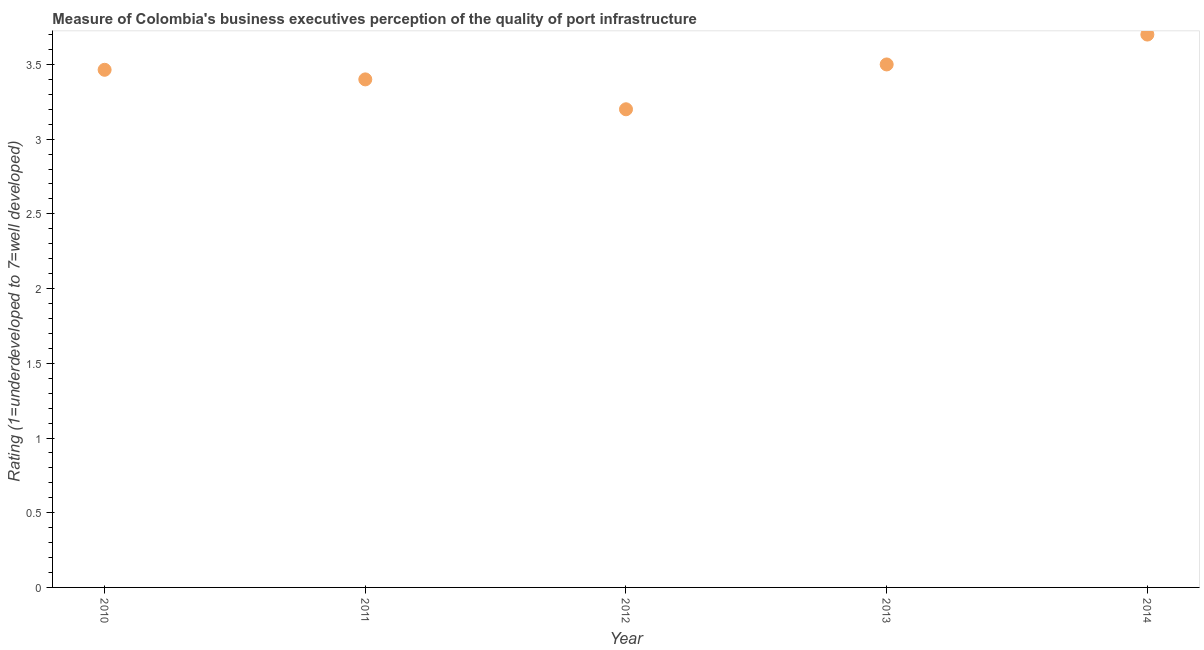What is the rating measuring quality of port infrastructure in 2011?
Your answer should be very brief. 3.4. Across all years, what is the maximum rating measuring quality of port infrastructure?
Offer a terse response. 3.7. Across all years, what is the minimum rating measuring quality of port infrastructure?
Your answer should be very brief. 3.2. In which year was the rating measuring quality of port infrastructure minimum?
Your answer should be compact. 2012. What is the sum of the rating measuring quality of port infrastructure?
Provide a short and direct response. 17.26. What is the difference between the rating measuring quality of port infrastructure in 2011 and 2013?
Offer a terse response. -0.1. What is the average rating measuring quality of port infrastructure per year?
Your answer should be compact. 3.45. What is the median rating measuring quality of port infrastructure?
Make the answer very short. 3.46. In how many years, is the rating measuring quality of port infrastructure greater than 2.2 ?
Ensure brevity in your answer.  5. Do a majority of the years between 2013 and 2010 (inclusive) have rating measuring quality of port infrastructure greater than 2.5 ?
Your response must be concise. Yes. What is the ratio of the rating measuring quality of port infrastructure in 2010 to that in 2013?
Give a very brief answer. 0.99. What is the difference between the highest and the second highest rating measuring quality of port infrastructure?
Make the answer very short. 0.2. Is the sum of the rating measuring quality of port infrastructure in 2011 and 2014 greater than the maximum rating measuring quality of port infrastructure across all years?
Ensure brevity in your answer.  Yes. In how many years, is the rating measuring quality of port infrastructure greater than the average rating measuring quality of port infrastructure taken over all years?
Give a very brief answer. 3. Does the rating measuring quality of port infrastructure monotonically increase over the years?
Your response must be concise. No. How many dotlines are there?
Keep it short and to the point. 1. What is the difference between two consecutive major ticks on the Y-axis?
Make the answer very short. 0.5. Are the values on the major ticks of Y-axis written in scientific E-notation?
Provide a succinct answer. No. Does the graph contain grids?
Your answer should be compact. No. What is the title of the graph?
Ensure brevity in your answer.  Measure of Colombia's business executives perception of the quality of port infrastructure. What is the label or title of the Y-axis?
Provide a short and direct response. Rating (1=underdeveloped to 7=well developed) . What is the Rating (1=underdeveloped to 7=well developed)  in 2010?
Offer a terse response. 3.46. What is the Rating (1=underdeveloped to 7=well developed)  in 2011?
Keep it short and to the point. 3.4. What is the Rating (1=underdeveloped to 7=well developed)  in 2012?
Make the answer very short. 3.2. What is the Rating (1=underdeveloped to 7=well developed)  in 2013?
Your response must be concise. 3.5. What is the difference between the Rating (1=underdeveloped to 7=well developed)  in 2010 and 2011?
Give a very brief answer. 0.06. What is the difference between the Rating (1=underdeveloped to 7=well developed)  in 2010 and 2012?
Your answer should be compact. 0.26. What is the difference between the Rating (1=underdeveloped to 7=well developed)  in 2010 and 2013?
Your answer should be very brief. -0.04. What is the difference between the Rating (1=underdeveloped to 7=well developed)  in 2010 and 2014?
Provide a succinct answer. -0.24. What is the difference between the Rating (1=underdeveloped to 7=well developed)  in 2011 and 2013?
Your response must be concise. -0.1. What is the ratio of the Rating (1=underdeveloped to 7=well developed)  in 2010 to that in 2012?
Offer a terse response. 1.08. What is the ratio of the Rating (1=underdeveloped to 7=well developed)  in 2010 to that in 2013?
Ensure brevity in your answer.  0.99. What is the ratio of the Rating (1=underdeveloped to 7=well developed)  in 2010 to that in 2014?
Provide a succinct answer. 0.94. What is the ratio of the Rating (1=underdeveloped to 7=well developed)  in 2011 to that in 2012?
Your answer should be very brief. 1.06. What is the ratio of the Rating (1=underdeveloped to 7=well developed)  in 2011 to that in 2014?
Provide a succinct answer. 0.92. What is the ratio of the Rating (1=underdeveloped to 7=well developed)  in 2012 to that in 2013?
Your response must be concise. 0.91. What is the ratio of the Rating (1=underdeveloped to 7=well developed)  in 2012 to that in 2014?
Provide a succinct answer. 0.86. What is the ratio of the Rating (1=underdeveloped to 7=well developed)  in 2013 to that in 2014?
Ensure brevity in your answer.  0.95. 